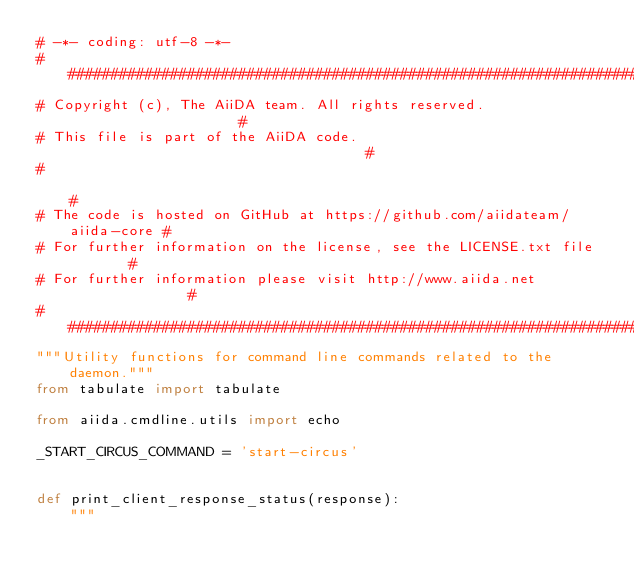Convert code to text. <code><loc_0><loc_0><loc_500><loc_500><_Python_># -*- coding: utf-8 -*-
###########################################################################
# Copyright (c), The AiiDA team. All rights reserved.                     #
# This file is part of the AiiDA code.                                    #
#                                                                         #
# The code is hosted on GitHub at https://github.com/aiidateam/aiida-core #
# For further information on the license, see the LICENSE.txt file        #
# For further information please visit http://www.aiida.net               #
###########################################################################
"""Utility functions for command line commands related to the daemon."""
from tabulate import tabulate

from aiida.cmdline.utils import echo

_START_CIRCUS_COMMAND = 'start-circus'


def print_client_response_status(response):
    """</code> 